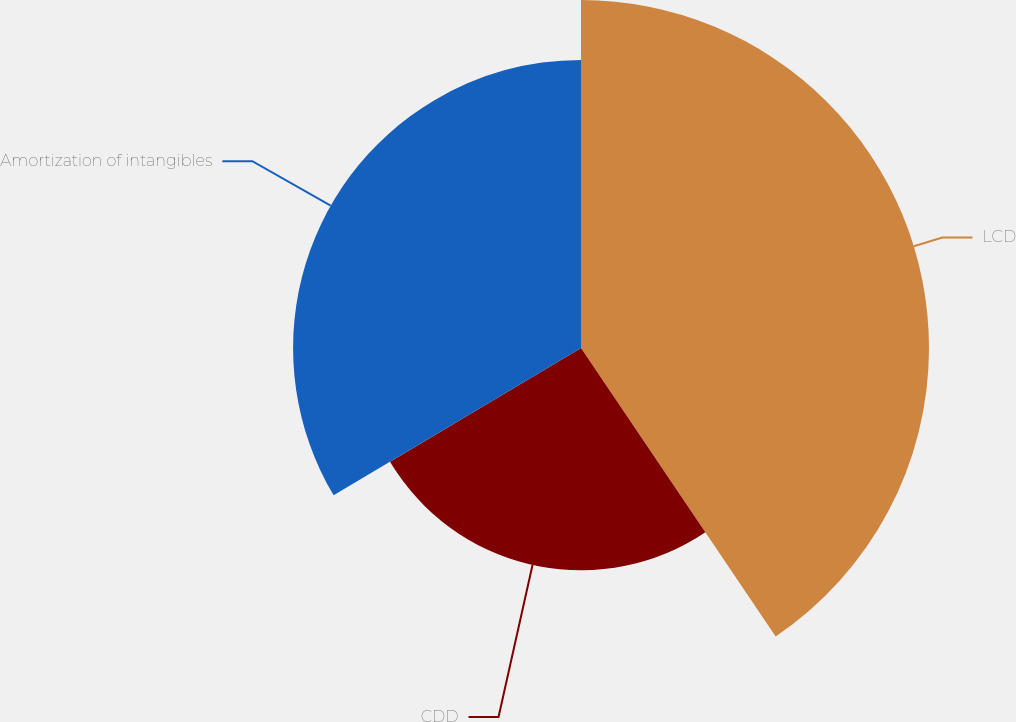Convert chart to OTSL. <chart><loc_0><loc_0><loc_500><loc_500><pie_chart><fcel>LCD<fcel>CDD<fcel>Amortization of intangibles<nl><fcel>40.55%<fcel>25.9%<fcel>33.55%<nl></chart> 